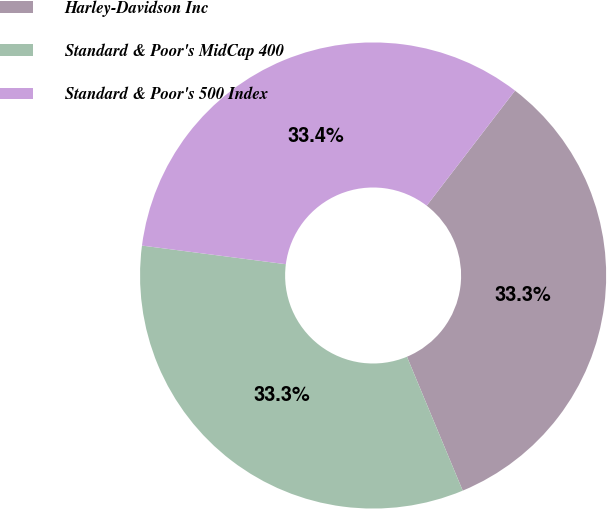Convert chart. <chart><loc_0><loc_0><loc_500><loc_500><pie_chart><fcel>Harley-Davidson Inc<fcel>Standard & Poor's MidCap 400<fcel>Standard & Poor's 500 Index<nl><fcel>33.3%<fcel>33.33%<fcel>33.37%<nl></chart> 